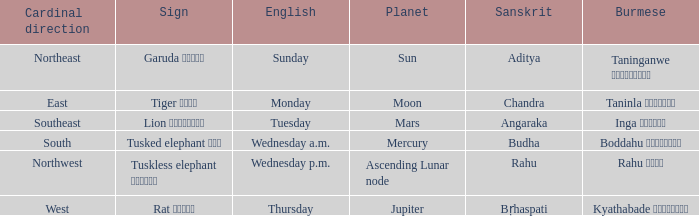State the name of day in english where cardinal direction is east Monday. Could you parse the entire table? {'header': ['Cardinal direction', 'Sign', 'English', 'Planet', 'Sanskrit', 'Burmese'], 'rows': [['Northeast', 'Garuda ဂဠုန်', 'Sunday', 'Sun', 'Aditya', 'Taninganwe တနင်္ဂနွေ'], ['East', 'Tiger ကျား', 'Monday', 'Moon', 'Chandra', 'Taninla တနင်္လာ'], ['Southeast', 'Lion ခြင်္သေ့', 'Tuesday', 'Mars', 'Angaraka', 'Inga အင်္ဂါ'], ['South', 'Tusked elephant ဆင်', 'Wednesday a.m.', 'Mercury', 'Budha', 'Boddahu ဗုဒ္ဓဟူး'], ['Northwest', 'Tuskless elephant ဟိုင်း', 'Wednesday p.m.', 'Ascending Lunar node', 'Rahu', 'Rahu ရာဟု'], ['West', 'Rat ကြွက်', 'Thursday', 'Jupiter', 'Bṛhaspati', 'Kyathabade ကြာသပတေး']]} 